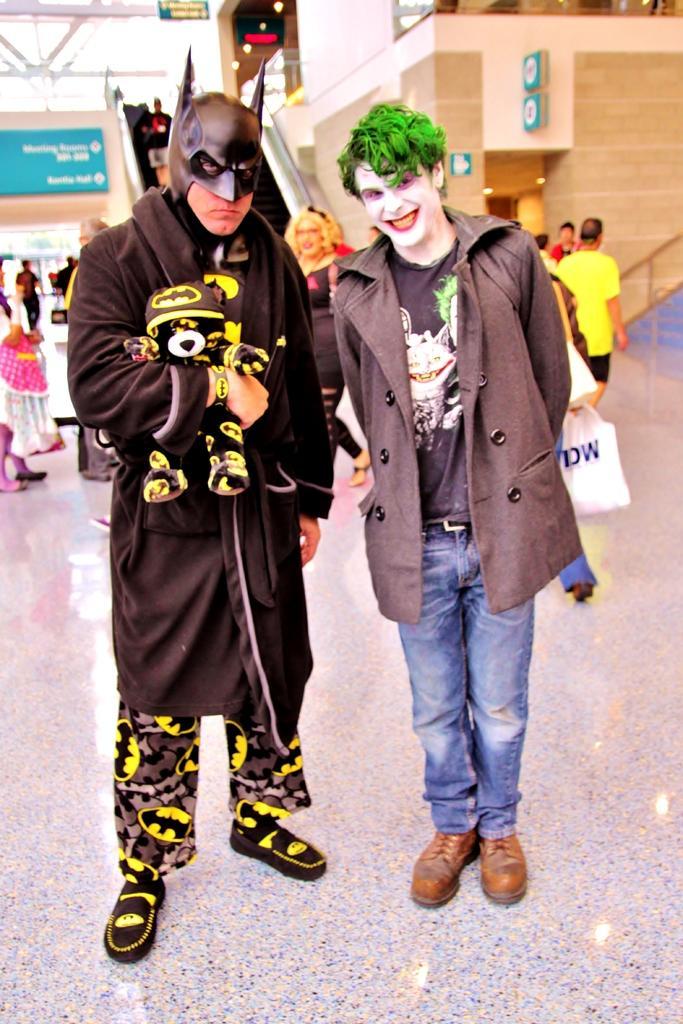Please provide a concise description of this image. To the left side of the image there is a man with black jacket is standing and holding a toy in his hands. And to his face there is a batman mask. Beside him there is a person with grey jacket and blue jeans is standing on the floor and there is a joker painting to his face. Behind them there is an escalator, wall with green posters. And to the top of the image to the left side there is a roof. 